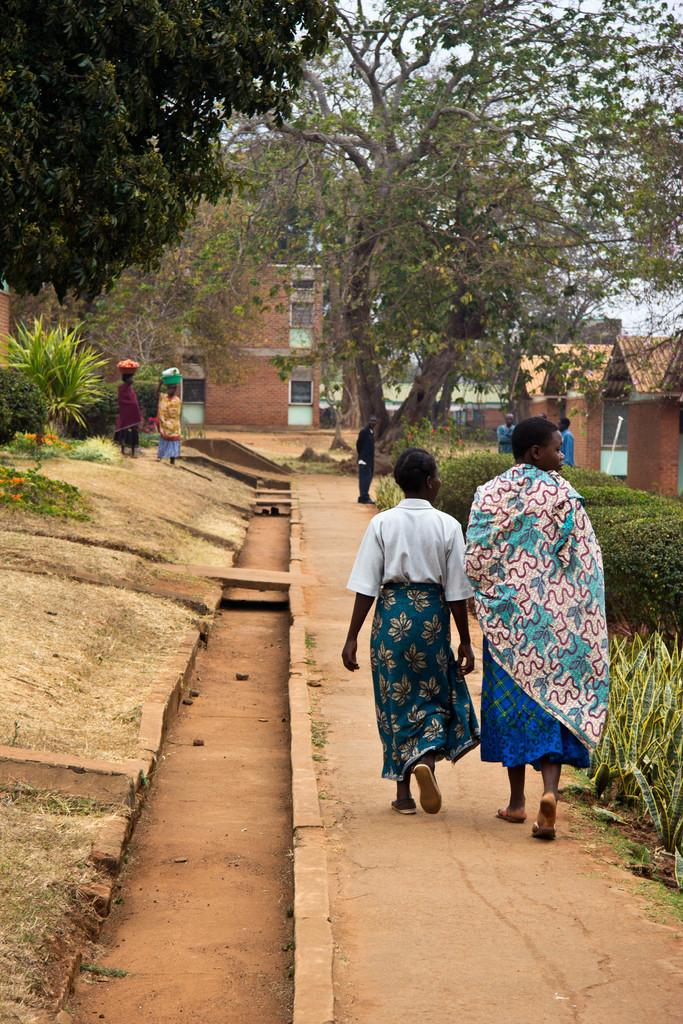What is happening on the right side of the image? There are two women walking on the right side of the image. What can be seen in the background of the image? There are trees in the image. What type of fan is visible in the image? There is no fan present in the image. What kind of food can be seen being prepared in the image? There is no food preparation visible in the image. 